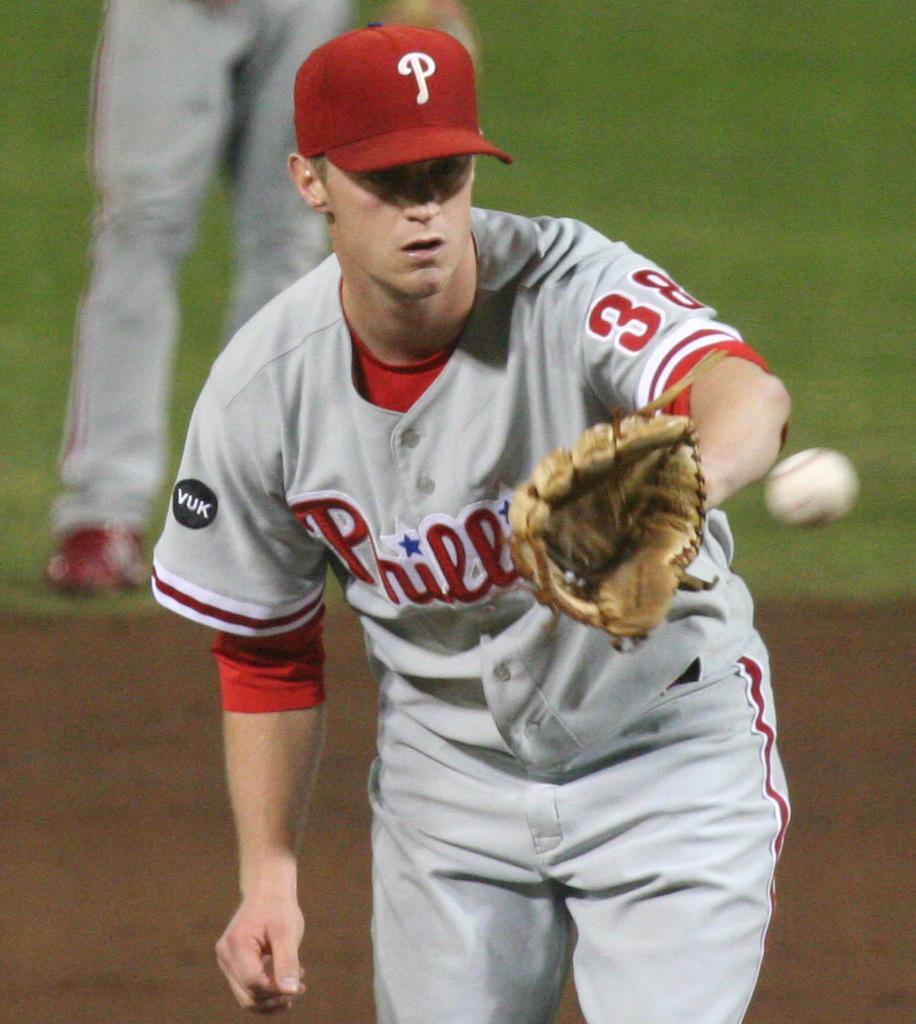How would you summarize this image in a sentence or two? In this image, we can see a person wearing clothes and glove. There is a ball on the right side of the image. There are person legs in the top left of the image. 